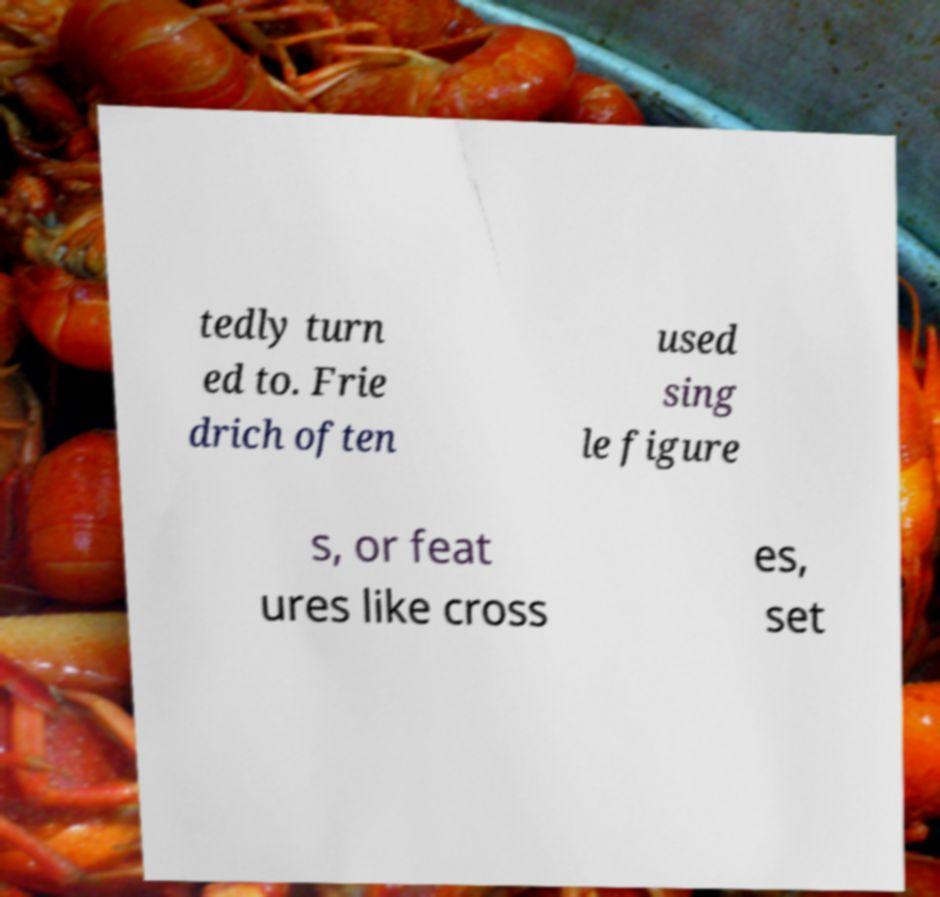Could you extract and type out the text from this image? tedly turn ed to. Frie drich often used sing le figure s, or feat ures like cross es, set 